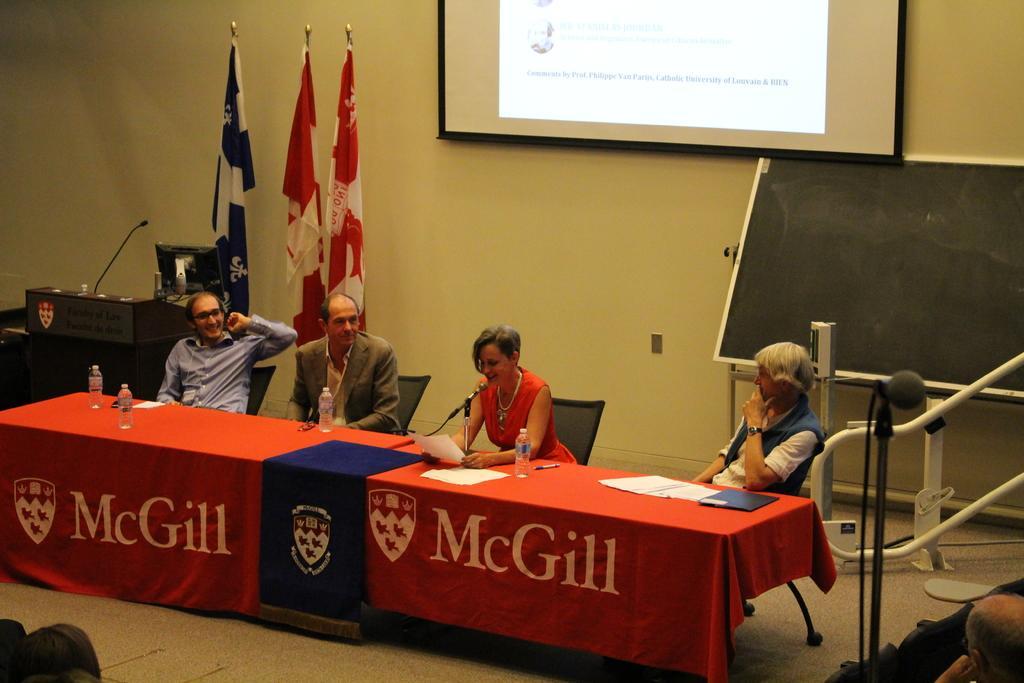Can you describe this image briefly? These four persons sitting on the chair. There is a table. On the table we can see bottles,paper,pen. on the background we can see wall,screen,board,flags,board. This is floor. 